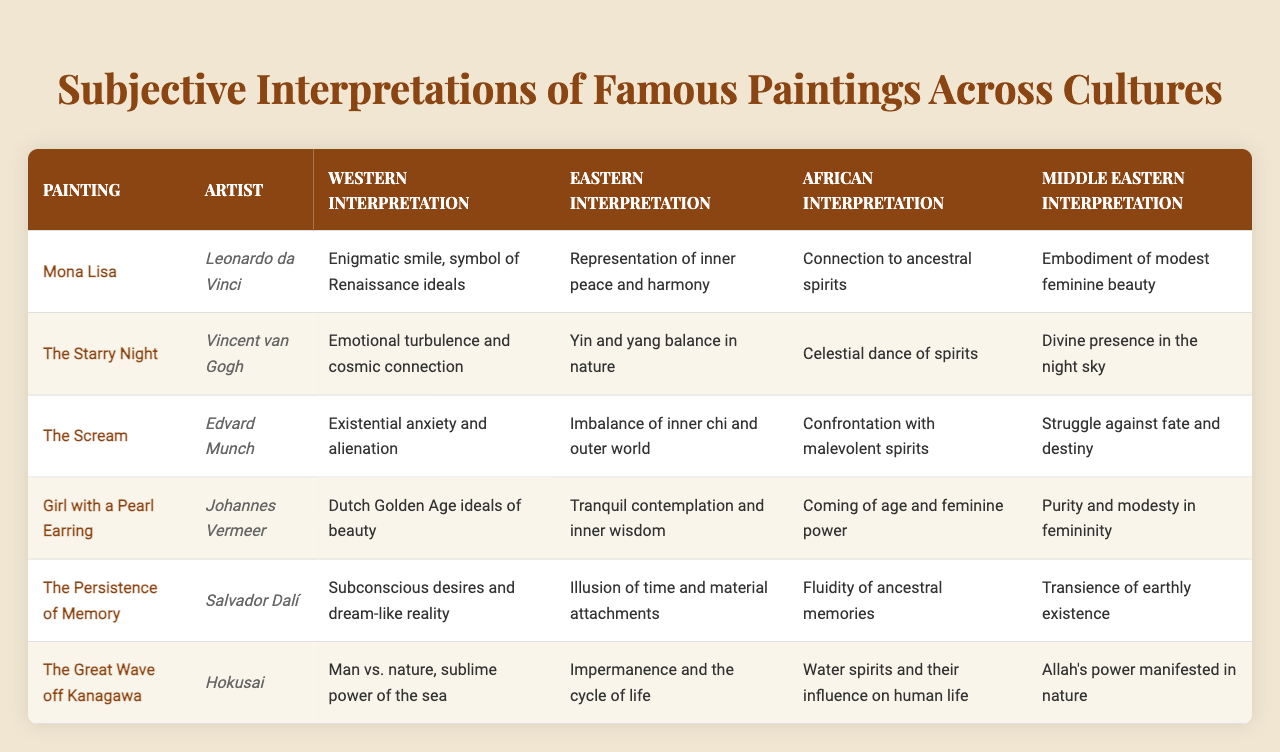What is the Western interpretation of "The Scream"? According to the table, the Western interpretation of "The Scream" is that it represents existential anxiety and alienation.
Answer: Existential anxiety and alienation What does the Eastern interpretation of "The Great Wave off Kanagawa" signify? The Eastern interpretation of "The Great Wave off Kanagawa" refers to impermanence and the cycle of life.
Answer: Impermanence and the cycle of life Which painting has a Middle Eastern interpretation relating to the purity and modesty of femininity? The painting "Girl with a Pearl Earring" has a Middle Eastern interpretation that relates to purity and modesty in femininity.
Answer: Girl with a Pearl Earring Which artist created "The Starry Night"? Vincent van Gogh is the artist who created "The Starry Night".
Answer: Vincent van Gogh What is one common theme found in African interpretations of "The Persistence of Memory" and "The Scream"? Both paintings in their African interpretations address spiritual and ancestral themes: "The Persistence of Memory" speaks to fluidity of ancestral memories, while "The Scream" confronts malevolent spirits.
Answer: Spiritual and ancestral themes How many interpretations are provided for each painting in the table? For each painting listed in the table, there are four interpretations provided: Western, Eastern, African, and Middle Eastern.
Answer: Four interpretations Is the interpretation of "The Great Wave off Kanagawa" consistent across cultures? The interpretations differ significantly across cultures, with Western focusing on man vs. nature, while the Eastern emphasizes impermanence, African highlights water spirits, and Middle Eastern sees Allah's power in nature.
Answer: No, they are not consistent What is the difference between the Western and African interpretations of "The Starry Night"? The Western interpretation highlights emotional turbulence and cosmic connection, while the African interpretation views it as a celestial dance of spirits. Hence, they reflect different cultural values: humanity's emotional connection versus spiritual presence.
Answer: Emotional turbulence vs. celestial dance Which painting expresses the theme of balance in both Eastern and Western interpretations? While both interpretations address balance, "The Starry Night" explicitly presents the theme of yin and yang balance in nature for the Eastern view, contrasting with Western emotional turmoil.
Answer: The Starry Night If I were to summarize the interpretations of "Mona Lisa" across cultures, what would be a key factor in each? The Western interpretation involves Renaissance ideals, the Eastern emphasizes harmony, the African connects ancestrally, and the Middle Eastern focuses on feminine beauty. Thus, all interpretations delve into different aspects of identity and aesthetics.
Answer: Identity and aesthetics Compare the interpretations of "The Persistence of Memory" and "The Great Wave off Kanagawa" in their cultural perspectives on nature. "The Persistence of Memory" discusses the illusion of time and material attachments, while "The Great Wave off Kanagawa" focuses on impermanence and the cycle of life. Each reflects a different relationship and understanding of nature: temporal versus cyclical.
Answer: Temporal vs. cyclical understanding of nature 